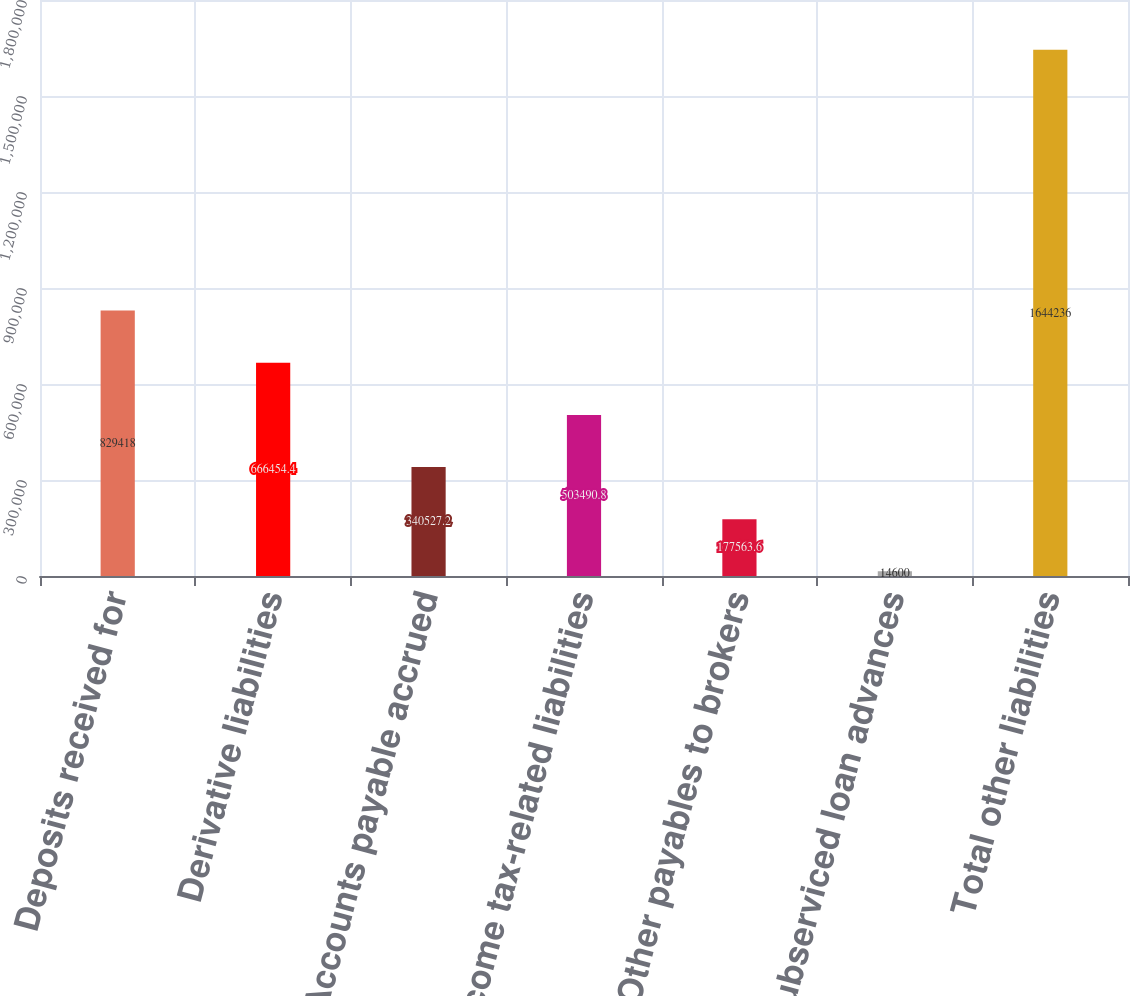Convert chart. <chart><loc_0><loc_0><loc_500><loc_500><bar_chart><fcel>Deposits received for<fcel>Derivative liabilities<fcel>Accounts payable accrued<fcel>Income tax-related liabilities<fcel>Other payables to brokers<fcel>Subserviced loan advances<fcel>Total other liabilities<nl><fcel>829418<fcel>666454<fcel>340527<fcel>503491<fcel>177564<fcel>14600<fcel>1.64424e+06<nl></chart> 